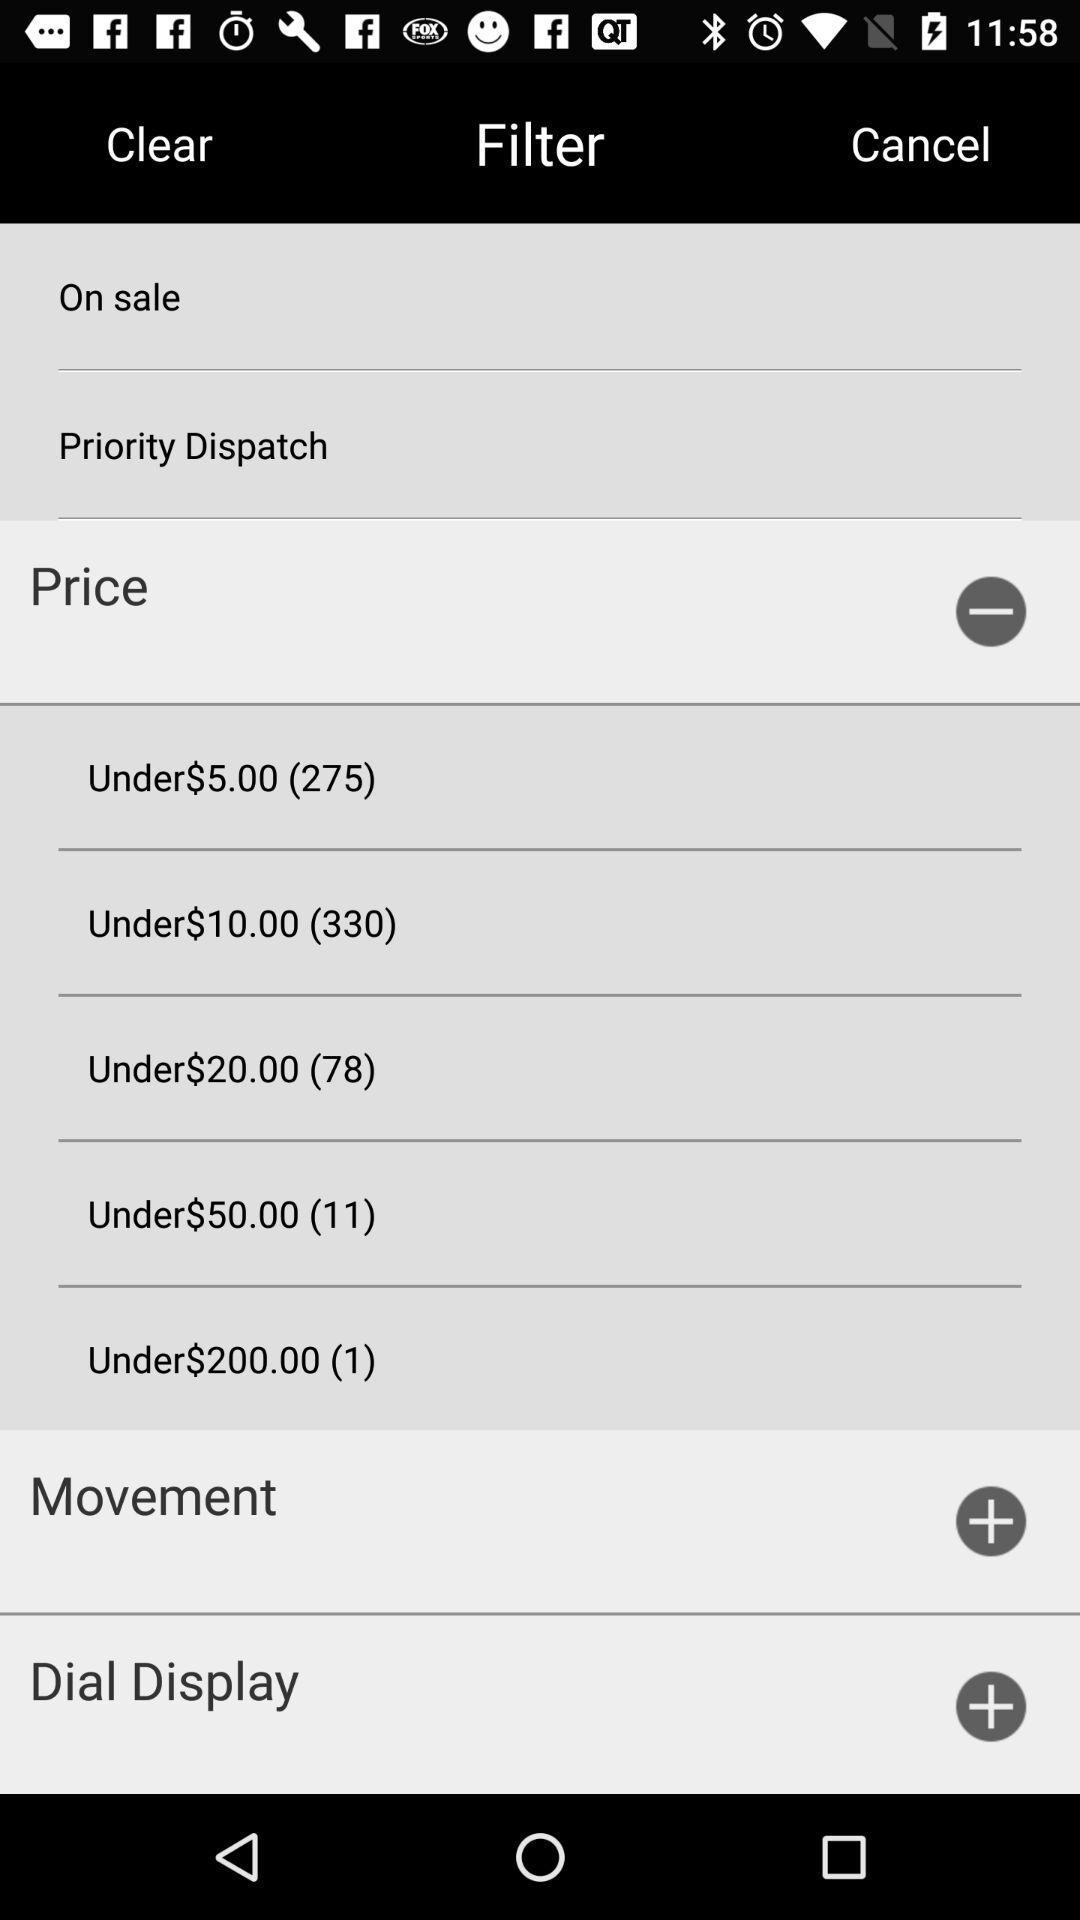How many products are there under the price of $5.00? There are 275 products under the price of $5.00. 